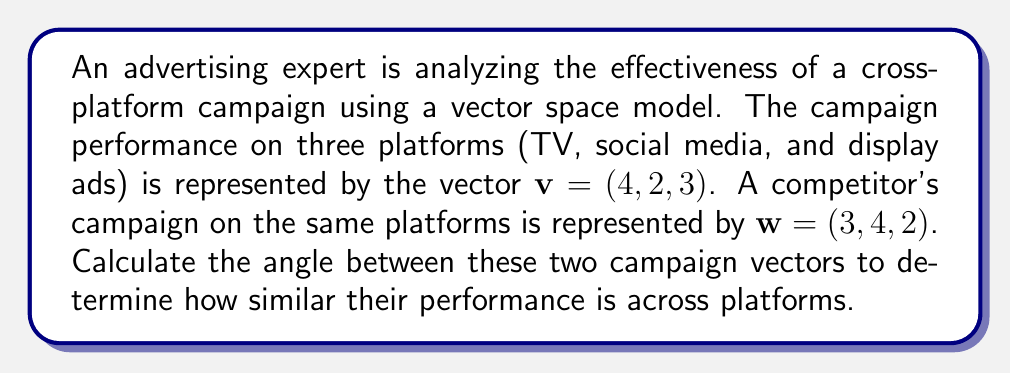Solve this math problem. To find the angle between two vectors in a vector space, we can use the dot product formula:

$$\cos \theta = \frac{v \cdot w}{||v|| \cdot ||w||}$$

Step 1: Calculate the dot product $v \cdot w$
$v \cdot w = 4(3) + 2(4) + 3(2) = 12 + 8 + 6 = 26$

Step 2: Calculate the magnitude of vector $v$
$||v|| = \sqrt{4^2 + 2^2 + 3^2} = \sqrt{16 + 4 + 9} = \sqrt{29}$

Step 3: Calculate the magnitude of vector $w$
$||w|| = \sqrt{3^2 + 4^2 + 2^2} = \sqrt{9 + 16 + 4} = \sqrt{29}$

Step 4: Apply the formula
$$\cos \theta = \frac{26}{\sqrt{29} \cdot \sqrt{29}} = \frac{26}{29}$$

Step 5: Take the inverse cosine (arccos) to find the angle
$$\theta = \arccos(\frac{26}{29}) \approx 0.3398 \text{ radians}$$

Step 6: Convert radians to degrees
$$\theta \approx 0.3398 \cdot \frac{180}{\pi} \approx 19.47°$$

The angle between the two campaign vectors is approximately 19.47 degrees, indicating a relatively high similarity in performance across platforms.
Answer: $19.47°$ 